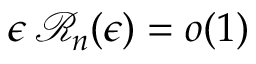Convert formula to latex. <formula><loc_0><loc_0><loc_500><loc_500>\epsilon \, { \mathcal { R } } _ { n } ( \epsilon ) = o ( 1 ) \,</formula> 